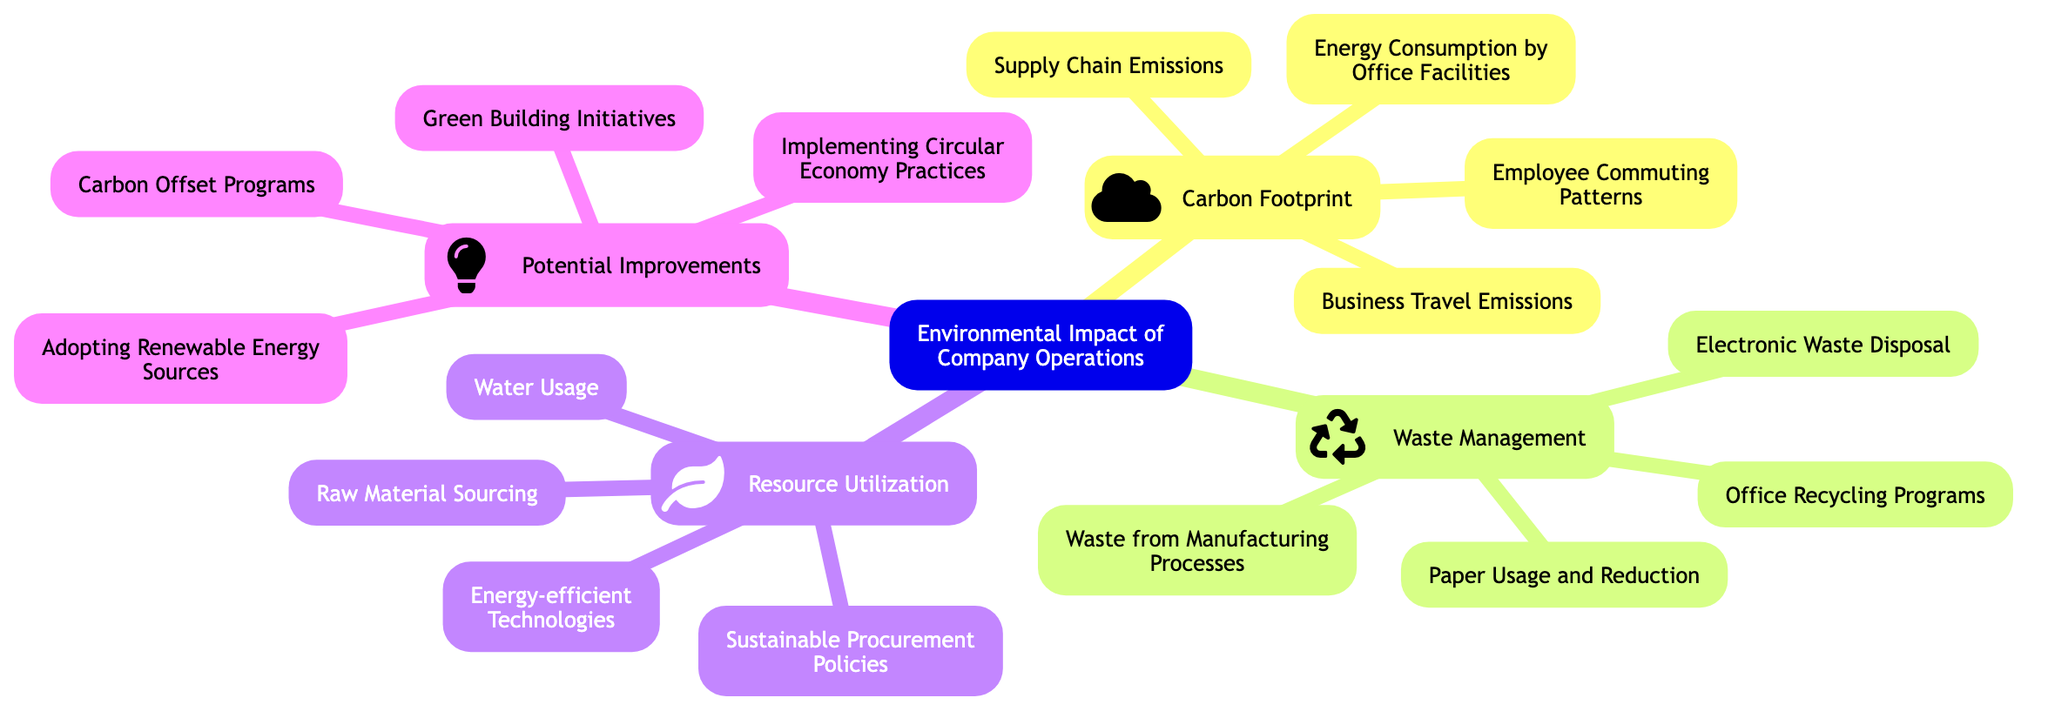What is the main topic of the mind map? The main topic is indicated at the root of the mind map, which provides the central theme of the diagram.
Answer: Environmental Impact of Company Operations How many subtopics are there in the mind map? The count of subtopics can be determined by identifying the distinct nodes under the main topic. There are four subtopics listed.
Answer: 4 What element is associated with Waste Management? By reviewing the subtopic for Waste Management, we can identify the various elements linked to it. One element in that set is "Office Recycling Programs".
Answer: Office Recycling Programs Which subtopic includes 'Energy-efficient Technologies'? To find this, we look at the various subtopics and check where 'Energy-efficient Technologies' falls, finding it listed under Resource Utilization.
Answer: Resource Utilization What improvement involves 'Renewable Energy Sources'? The mention of 'Adopting Renewable Energy Sources' can be found under the Potential Improvements subtopic.
Answer: Adopting Renewable Energy Sources Which two subtopics focus on reducing environmental impact? By identifying the subtopics that aim towards minimizing negative effects, Waste Management and Potential Improvements can be recognized as focused on reducing environmental impact.
Answer: Waste Management and Potential Improvements How many elements are there under Carbon Footprint? To determine this, you would count each listed element in the Carbon Footprint subtopic. There are four elements detailed here.
Answer: 4 What is the first element listed under Resource Utilization? The elements listed under Resource Utilization can be referenced, with 'Water Usage' as the first listed item.
Answer: Water Usage Which subtopic icon includes the feather symbol? The icon associated with the feather symbol (fa fa-leaf) corresponds with the Resource Utilization subtopic, indicating its connection to nature and resources.
Answer: Resource Utilization 